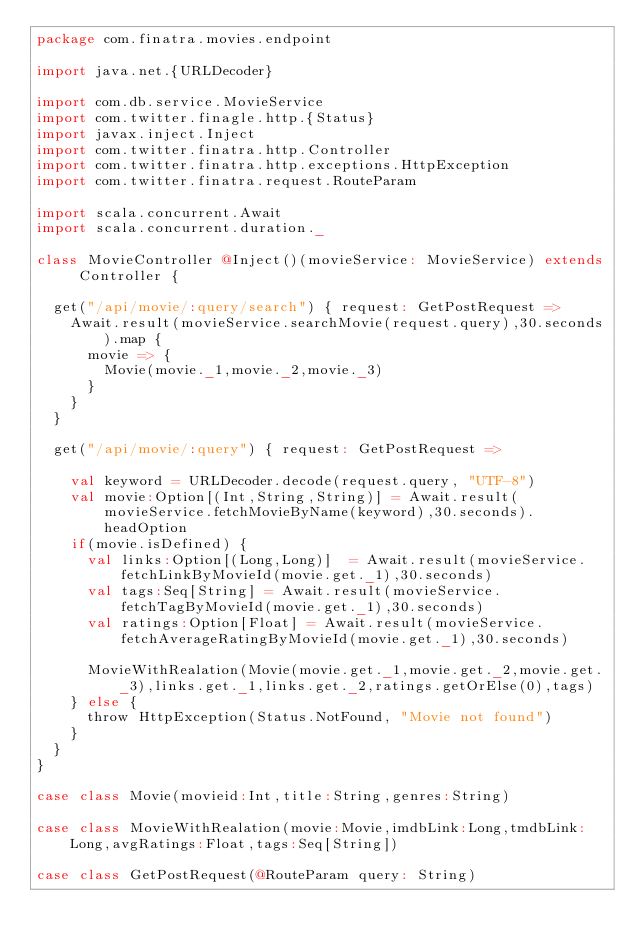<code> <loc_0><loc_0><loc_500><loc_500><_Scala_>package com.finatra.movies.endpoint

import java.net.{URLDecoder}

import com.db.service.MovieService
import com.twitter.finagle.http.{Status}
import javax.inject.Inject
import com.twitter.finatra.http.Controller
import com.twitter.finatra.http.exceptions.HttpException
import com.twitter.finatra.request.RouteParam

import scala.concurrent.Await
import scala.concurrent.duration._

class MovieController @Inject()(movieService: MovieService) extends Controller {

  get("/api/movie/:query/search") { request: GetPostRequest =>
    Await.result(movieService.searchMovie(request.query),30.seconds).map {
      movie => {
        Movie(movie._1,movie._2,movie._3)
      }
    }
  }

  get("/api/movie/:query") { request: GetPostRequest =>

    val keyword = URLDecoder.decode(request.query, "UTF-8")
    val movie:Option[(Int,String,String)] = Await.result(movieService.fetchMovieByName(keyword),30.seconds).headOption
    if(movie.isDefined) {
      val links:Option[(Long,Long)]  = Await.result(movieService.fetchLinkByMovieId(movie.get._1),30.seconds)
      val tags:Seq[String] = Await.result(movieService.fetchTagByMovieId(movie.get._1),30.seconds)
      val ratings:Option[Float] = Await.result(movieService.fetchAverageRatingByMovieId(movie.get._1),30.seconds)

      MovieWithRealation(Movie(movie.get._1,movie.get._2,movie.get._3),links.get._1,links.get._2,ratings.getOrElse(0),tags)
    } else {
      throw HttpException(Status.NotFound, "Movie not found")
    }
  }
}

case class Movie(movieid:Int,title:String,genres:String)

case class MovieWithRealation(movie:Movie,imdbLink:Long,tmdbLink:Long,avgRatings:Float,tags:Seq[String])

case class GetPostRequest(@RouteParam query: String)






</code> 